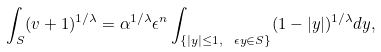<formula> <loc_0><loc_0><loc_500><loc_500>\int _ { S } ( v + 1 ) ^ { 1 / \lambda } = \alpha ^ { 1 / \lambda } \epsilon ^ { n } \int _ { \{ | y | \leq 1 , \ \epsilon y \in S \} } ( 1 - | y | ) ^ { 1 / \lambda } d y ,</formula> 